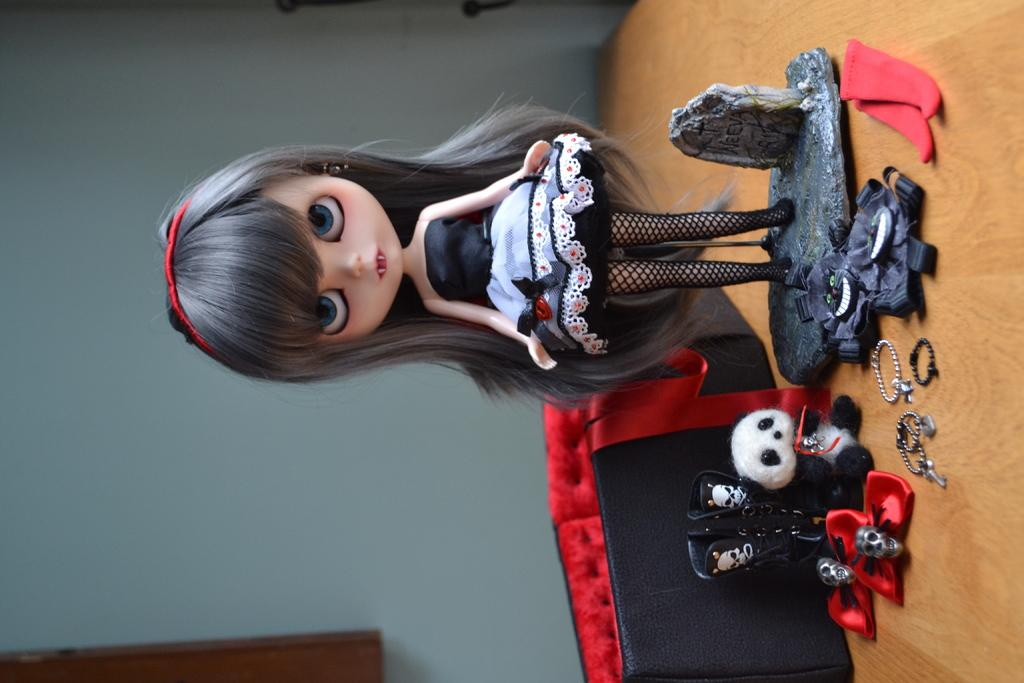What is the main subject in the middle of the image? There is a doll in the middle of the image. What other items can be seen in the image? There are toys, a bag, and a ring in the image. What is visible in the background of the image? There is a wall in the background of the image. What type of calculator is being used to talk to the doll in the image? There is no calculator or talking involved in the image; it features a doll and other objects. 